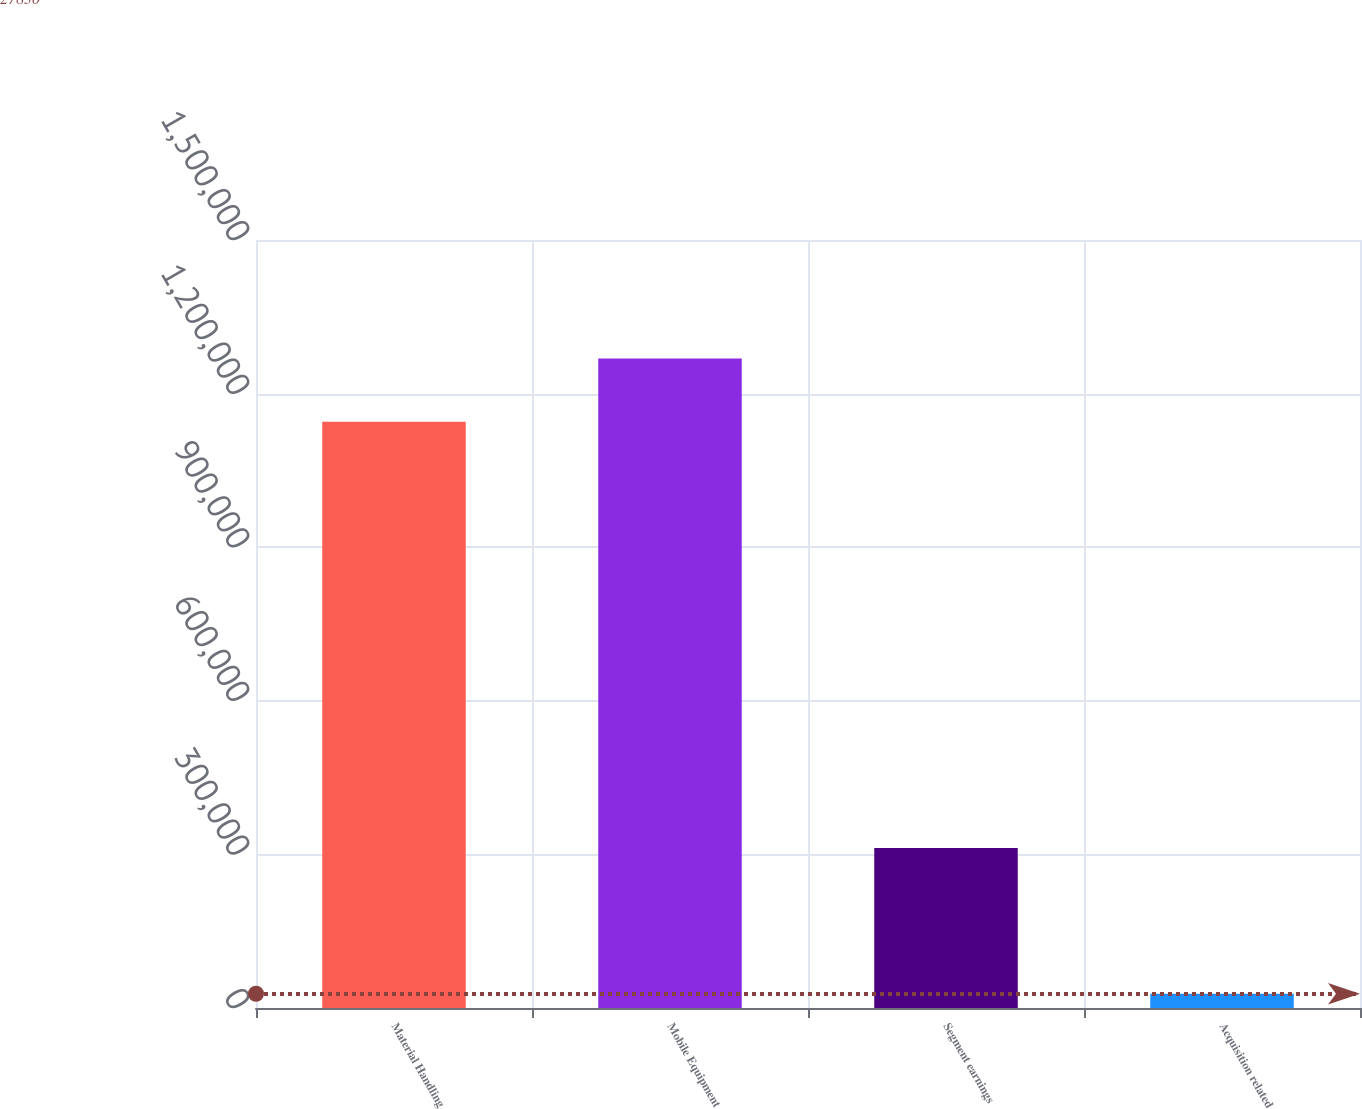<chart> <loc_0><loc_0><loc_500><loc_500><bar_chart><fcel>Material Handling<fcel>Mobile Equipment<fcel>Segment earnings<fcel>Acquisition related<nl><fcel>1.14525e+06<fcel>1.26877e+06<fcel>312486<fcel>27830<nl></chart> 